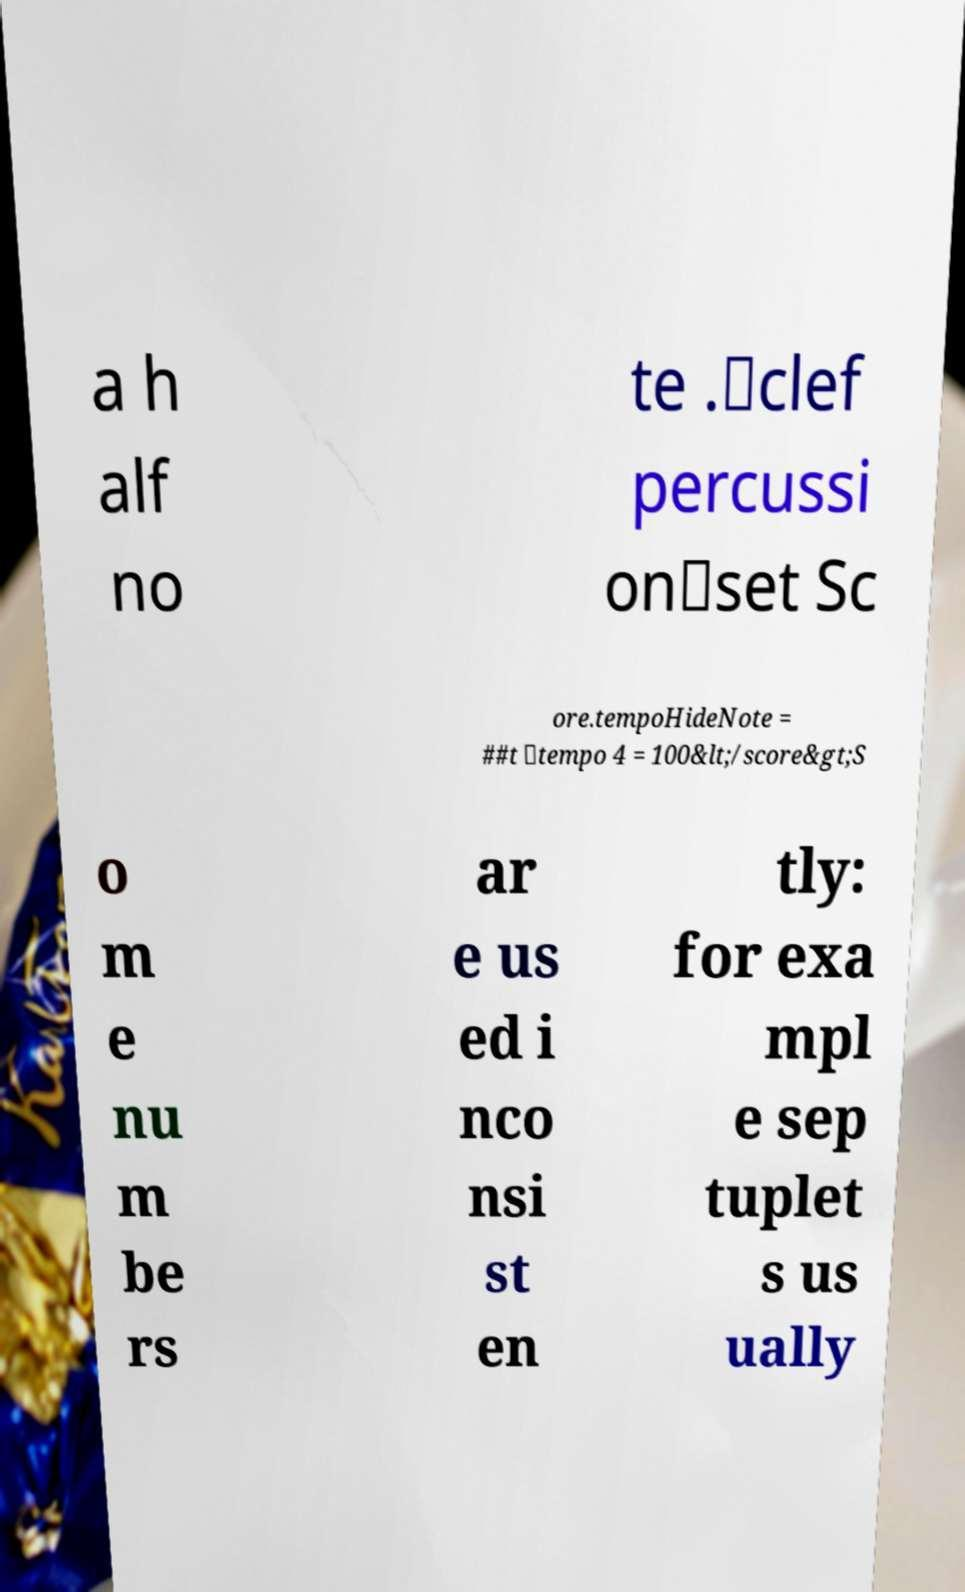Please identify and transcribe the text found in this image. a h alf no te .\clef percussi on\set Sc ore.tempoHideNote = ##t \tempo 4 = 100&lt;/score&gt;S o m e nu m be rs ar e us ed i nco nsi st en tly: for exa mpl e sep tuplet s us ually 